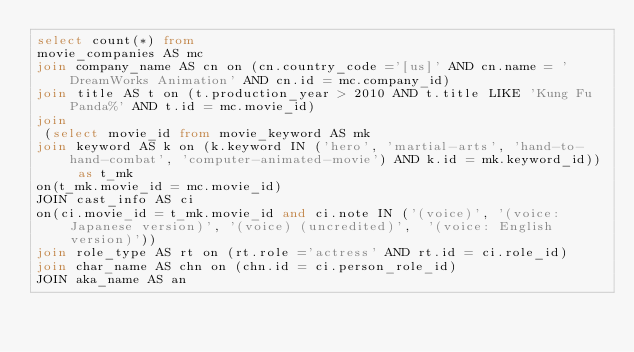<code> <loc_0><loc_0><loc_500><loc_500><_SQL_>select count(*) from 
movie_companies AS mc 
join company_name AS cn on (cn.country_code ='[us]' AND cn.name = 'DreamWorks Animation' AND cn.id = mc.company_id)
join title AS t on (t.production_year > 2010 AND t.title LIKE 'Kung Fu Panda%' AND t.id = mc.movie_id)
join
 (select movie_id from movie_keyword AS mk 
join keyword AS k on (k.keyword IN ('hero', 'martial-arts', 'hand-to-hand-combat', 'computer-animated-movie') AND k.id = mk.keyword_id)) as t_mk 
on(t_mk.movie_id = mc.movie_id)
JOIN cast_info AS ci  
on(ci.movie_id = t_mk.movie_id and ci.note IN ('(voice)', '(voice: Japanese version)', '(voice) (uncredited)',  '(voice: English version)'))
join role_type AS rt on (rt.role ='actress' AND rt.id = ci.role_id)
join char_name AS chn on (chn.id = ci.person_role_id)
JOIN aka_name AS an  </code> 